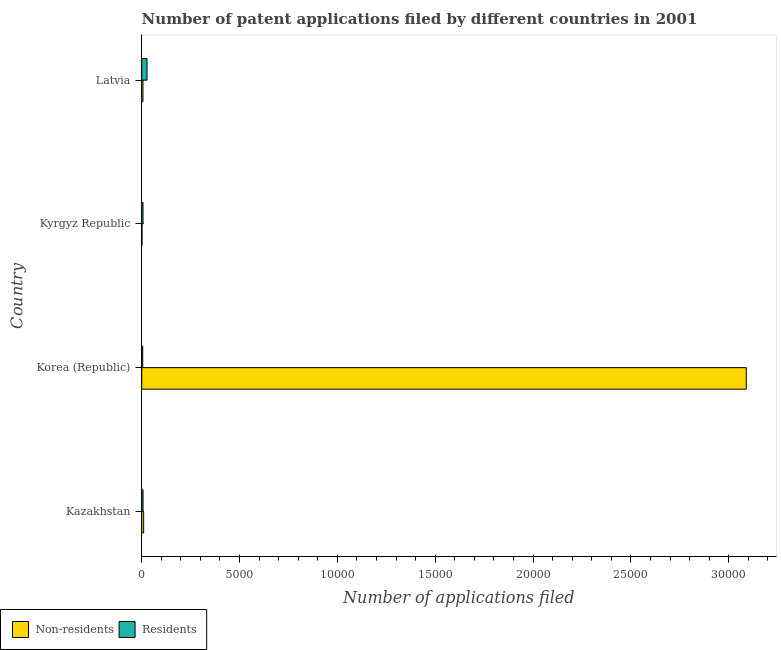How many groups of bars are there?
Keep it short and to the point. 4. Are the number of bars per tick equal to the number of legend labels?
Provide a succinct answer. Yes. Are the number of bars on each tick of the Y-axis equal?
Your answer should be compact. Yes. How many bars are there on the 2nd tick from the bottom?
Your response must be concise. 2. What is the label of the 4th group of bars from the top?
Provide a short and direct response. Kazakhstan. In how many cases, is the number of bars for a given country not equal to the number of legend labels?
Offer a very short reply. 0. What is the number of patent applications by non residents in Kazakhstan?
Offer a terse response. 99. Across all countries, what is the maximum number of patent applications by non residents?
Make the answer very short. 3.09e+04. Across all countries, what is the minimum number of patent applications by non residents?
Provide a succinct answer. 14. What is the total number of patent applications by residents in the graph?
Provide a short and direct response. 456. What is the difference between the number of patent applications by non residents in Kazakhstan and that in Korea (Republic)?
Offer a very short reply. -3.08e+04. What is the difference between the number of patent applications by non residents in Kyrgyz Republic and the number of patent applications by residents in Kazakhstan?
Your answer should be very brief. -54. What is the average number of patent applications by residents per country?
Give a very brief answer. 114. What is the difference between the number of patent applications by non residents and number of patent applications by residents in Latvia?
Your answer should be compact. -208. What is the ratio of the number of patent applications by non residents in Kazakhstan to that in Latvia?
Make the answer very short. 1.57. What is the difference between the highest and the second highest number of patent applications by residents?
Make the answer very short. 203. What is the difference between the highest and the lowest number of patent applications by non residents?
Your response must be concise. 3.09e+04. Is the sum of the number of patent applications by residents in Kyrgyz Republic and Latvia greater than the maximum number of patent applications by non residents across all countries?
Ensure brevity in your answer.  No. What does the 1st bar from the top in Kyrgyz Republic represents?
Keep it short and to the point. Residents. What does the 1st bar from the bottom in Kazakhstan represents?
Make the answer very short. Non-residents. Are all the bars in the graph horizontal?
Provide a short and direct response. Yes. Where does the legend appear in the graph?
Provide a succinct answer. Bottom left. What is the title of the graph?
Your response must be concise. Number of patent applications filed by different countries in 2001. What is the label or title of the X-axis?
Your answer should be very brief. Number of applications filed. What is the label or title of the Y-axis?
Make the answer very short. Country. What is the Number of applications filed of Non-residents in Kazakhstan?
Your response must be concise. 99. What is the Number of applications filed in Residents in Kazakhstan?
Your answer should be very brief. 68. What is the Number of applications filed of Non-residents in Korea (Republic)?
Your response must be concise. 3.09e+04. What is the Number of applications filed of Non-residents in Kyrgyz Republic?
Offer a very short reply. 14. What is the Number of applications filed in Residents in Kyrgyz Republic?
Offer a terse response. 66. What is the Number of applications filed in Non-residents in Latvia?
Provide a short and direct response. 63. What is the Number of applications filed in Residents in Latvia?
Your response must be concise. 271. Across all countries, what is the maximum Number of applications filed in Non-residents?
Give a very brief answer. 3.09e+04. Across all countries, what is the maximum Number of applications filed in Residents?
Ensure brevity in your answer.  271. Across all countries, what is the minimum Number of applications filed of Residents?
Provide a succinct answer. 51. What is the total Number of applications filed of Non-residents in the graph?
Ensure brevity in your answer.  3.11e+04. What is the total Number of applications filed in Residents in the graph?
Keep it short and to the point. 456. What is the difference between the Number of applications filed in Non-residents in Kazakhstan and that in Korea (Republic)?
Your answer should be compact. -3.08e+04. What is the difference between the Number of applications filed in Residents in Kazakhstan and that in Korea (Republic)?
Ensure brevity in your answer.  17. What is the difference between the Number of applications filed of Non-residents in Kazakhstan and that in Kyrgyz Republic?
Provide a succinct answer. 85. What is the difference between the Number of applications filed in Residents in Kazakhstan and that in Latvia?
Provide a succinct answer. -203. What is the difference between the Number of applications filed of Non-residents in Korea (Republic) and that in Kyrgyz Republic?
Offer a very short reply. 3.09e+04. What is the difference between the Number of applications filed of Residents in Korea (Republic) and that in Kyrgyz Republic?
Your response must be concise. -15. What is the difference between the Number of applications filed in Non-residents in Korea (Republic) and that in Latvia?
Offer a very short reply. 3.08e+04. What is the difference between the Number of applications filed of Residents in Korea (Republic) and that in Latvia?
Offer a terse response. -220. What is the difference between the Number of applications filed in Non-residents in Kyrgyz Republic and that in Latvia?
Offer a very short reply. -49. What is the difference between the Number of applications filed in Residents in Kyrgyz Republic and that in Latvia?
Give a very brief answer. -205. What is the difference between the Number of applications filed of Non-residents in Kazakhstan and the Number of applications filed of Residents in Korea (Republic)?
Provide a succinct answer. 48. What is the difference between the Number of applications filed of Non-residents in Kazakhstan and the Number of applications filed of Residents in Latvia?
Your answer should be compact. -172. What is the difference between the Number of applications filed of Non-residents in Korea (Republic) and the Number of applications filed of Residents in Kyrgyz Republic?
Ensure brevity in your answer.  3.08e+04. What is the difference between the Number of applications filed in Non-residents in Korea (Republic) and the Number of applications filed in Residents in Latvia?
Your response must be concise. 3.06e+04. What is the difference between the Number of applications filed of Non-residents in Kyrgyz Republic and the Number of applications filed of Residents in Latvia?
Ensure brevity in your answer.  -257. What is the average Number of applications filed of Non-residents per country?
Offer a very short reply. 7768.5. What is the average Number of applications filed in Residents per country?
Ensure brevity in your answer.  114. What is the difference between the Number of applications filed in Non-residents and Number of applications filed in Residents in Korea (Republic)?
Make the answer very short. 3.08e+04. What is the difference between the Number of applications filed in Non-residents and Number of applications filed in Residents in Kyrgyz Republic?
Provide a succinct answer. -52. What is the difference between the Number of applications filed in Non-residents and Number of applications filed in Residents in Latvia?
Provide a short and direct response. -208. What is the ratio of the Number of applications filed of Non-residents in Kazakhstan to that in Korea (Republic)?
Provide a short and direct response. 0. What is the ratio of the Number of applications filed in Residents in Kazakhstan to that in Korea (Republic)?
Offer a very short reply. 1.33. What is the ratio of the Number of applications filed in Non-residents in Kazakhstan to that in Kyrgyz Republic?
Offer a terse response. 7.07. What is the ratio of the Number of applications filed of Residents in Kazakhstan to that in Kyrgyz Republic?
Provide a short and direct response. 1.03. What is the ratio of the Number of applications filed of Non-residents in Kazakhstan to that in Latvia?
Your answer should be very brief. 1.57. What is the ratio of the Number of applications filed of Residents in Kazakhstan to that in Latvia?
Keep it short and to the point. 0.25. What is the ratio of the Number of applications filed in Non-residents in Korea (Republic) to that in Kyrgyz Republic?
Offer a terse response. 2207. What is the ratio of the Number of applications filed in Residents in Korea (Republic) to that in Kyrgyz Republic?
Your response must be concise. 0.77. What is the ratio of the Number of applications filed of Non-residents in Korea (Republic) to that in Latvia?
Offer a terse response. 490.44. What is the ratio of the Number of applications filed of Residents in Korea (Republic) to that in Latvia?
Provide a succinct answer. 0.19. What is the ratio of the Number of applications filed of Non-residents in Kyrgyz Republic to that in Latvia?
Give a very brief answer. 0.22. What is the ratio of the Number of applications filed in Residents in Kyrgyz Republic to that in Latvia?
Your response must be concise. 0.24. What is the difference between the highest and the second highest Number of applications filed of Non-residents?
Offer a very short reply. 3.08e+04. What is the difference between the highest and the second highest Number of applications filed of Residents?
Your response must be concise. 203. What is the difference between the highest and the lowest Number of applications filed in Non-residents?
Make the answer very short. 3.09e+04. What is the difference between the highest and the lowest Number of applications filed of Residents?
Your response must be concise. 220. 